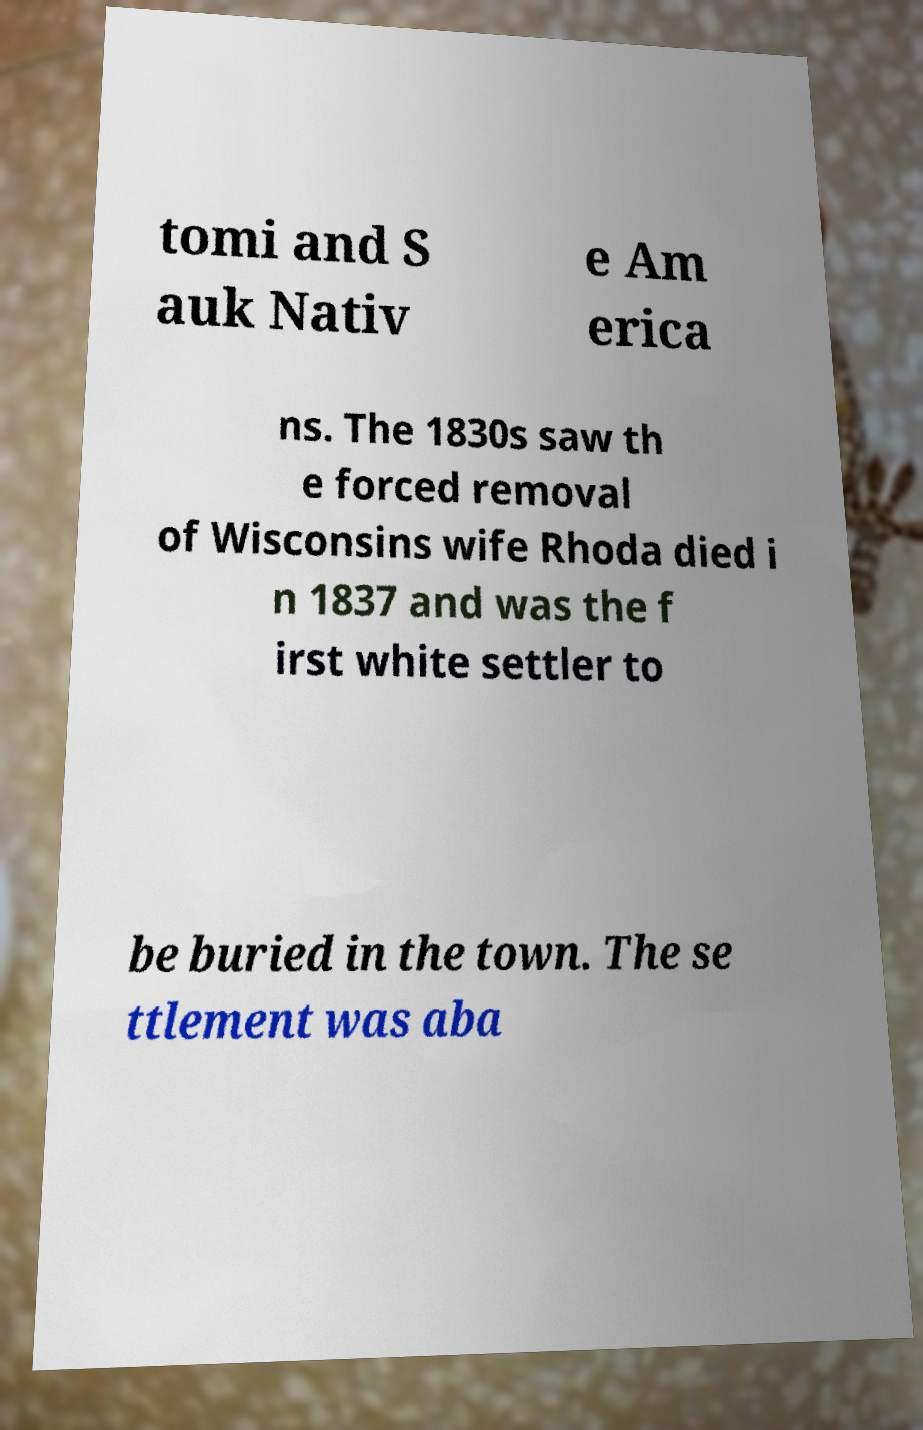For documentation purposes, I need the text within this image transcribed. Could you provide that? tomi and S auk Nativ e Am erica ns. The 1830s saw th e forced removal of Wisconsins wife Rhoda died i n 1837 and was the f irst white settler to be buried in the town. The se ttlement was aba 